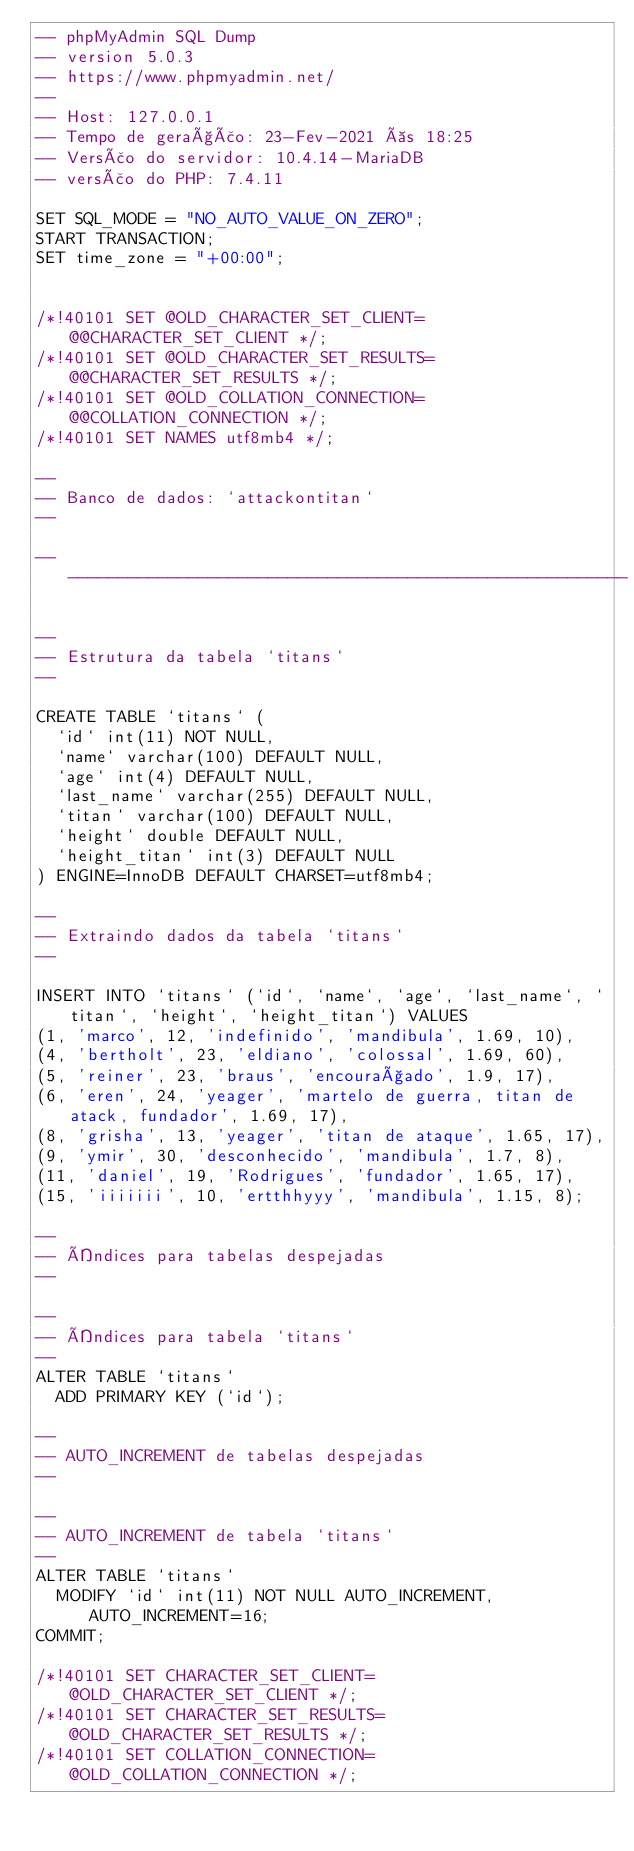Convert code to text. <code><loc_0><loc_0><loc_500><loc_500><_SQL_>-- phpMyAdmin SQL Dump
-- version 5.0.3
-- https://www.phpmyadmin.net/
--
-- Host: 127.0.0.1
-- Tempo de geração: 23-Fev-2021 às 18:25
-- Versão do servidor: 10.4.14-MariaDB
-- versão do PHP: 7.4.11

SET SQL_MODE = "NO_AUTO_VALUE_ON_ZERO";
START TRANSACTION;
SET time_zone = "+00:00";


/*!40101 SET @OLD_CHARACTER_SET_CLIENT=@@CHARACTER_SET_CLIENT */;
/*!40101 SET @OLD_CHARACTER_SET_RESULTS=@@CHARACTER_SET_RESULTS */;
/*!40101 SET @OLD_COLLATION_CONNECTION=@@COLLATION_CONNECTION */;
/*!40101 SET NAMES utf8mb4 */;

--
-- Banco de dados: `attackontitan`
--

-- --------------------------------------------------------

--
-- Estrutura da tabela `titans`
--

CREATE TABLE `titans` (
  `id` int(11) NOT NULL,
  `name` varchar(100) DEFAULT NULL,
  `age` int(4) DEFAULT NULL,
  `last_name` varchar(255) DEFAULT NULL,
  `titan` varchar(100) DEFAULT NULL,
  `height` double DEFAULT NULL,
  `height_titan` int(3) DEFAULT NULL
) ENGINE=InnoDB DEFAULT CHARSET=utf8mb4;

--
-- Extraindo dados da tabela `titans`
--

INSERT INTO `titans` (`id`, `name`, `age`, `last_name`, `titan`, `height`, `height_titan`) VALUES
(1, 'marco', 12, 'indefinido', 'mandibula', 1.69, 10),
(4, 'bertholt', 23, 'eldiano', 'colossal', 1.69, 60),
(5, 'reiner', 23, 'braus', 'encouraçado', 1.9, 17),
(6, 'eren', 24, 'yeager', 'martelo de guerra, titan de atack, fundador', 1.69, 17),
(8, 'grisha', 13, 'yeager', 'titan de ataque', 1.65, 17),
(9, 'ymir', 30, 'desconhecido', 'mandibula', 1.7, 8),
(11, 'daniel', 19, 'Rodrigues', 'fundador', 1.65, 17),
(15, 'iiiiiii', 10, 'ertthhyyy', 'mandibula', 1.15, 8);

--
-- Índices para tabelas despejadas
--

--
-- Índices para tabela `titans`
--
ALTER TABLE `titans`
  ADD PRIMARY KEY (`id`);

--
-- AUTO_INCREMENT de tabelas despejadas
--

--
-- AUTO_INCREMENT de tabela `titans`
--
ALTER TABLE `titans`
  MODIFY `id` int(11) NOT NULL AUTO_INCREMENT, AUTO_INCREMENT=16;
COMMIT;

/*!40101 SET CHARACTER_SET_CLIENT=@OLD_CHARACTER_SET_CLIENT */;
/*!40101 SET CHARACTER_SET_RESULTS=@OLD_CHARACTER_SET_RESULTS */;
/*!40101 SET COLLATION_CONNECTION=@OLD_COLLATION_CONNECTION */;
</code> 